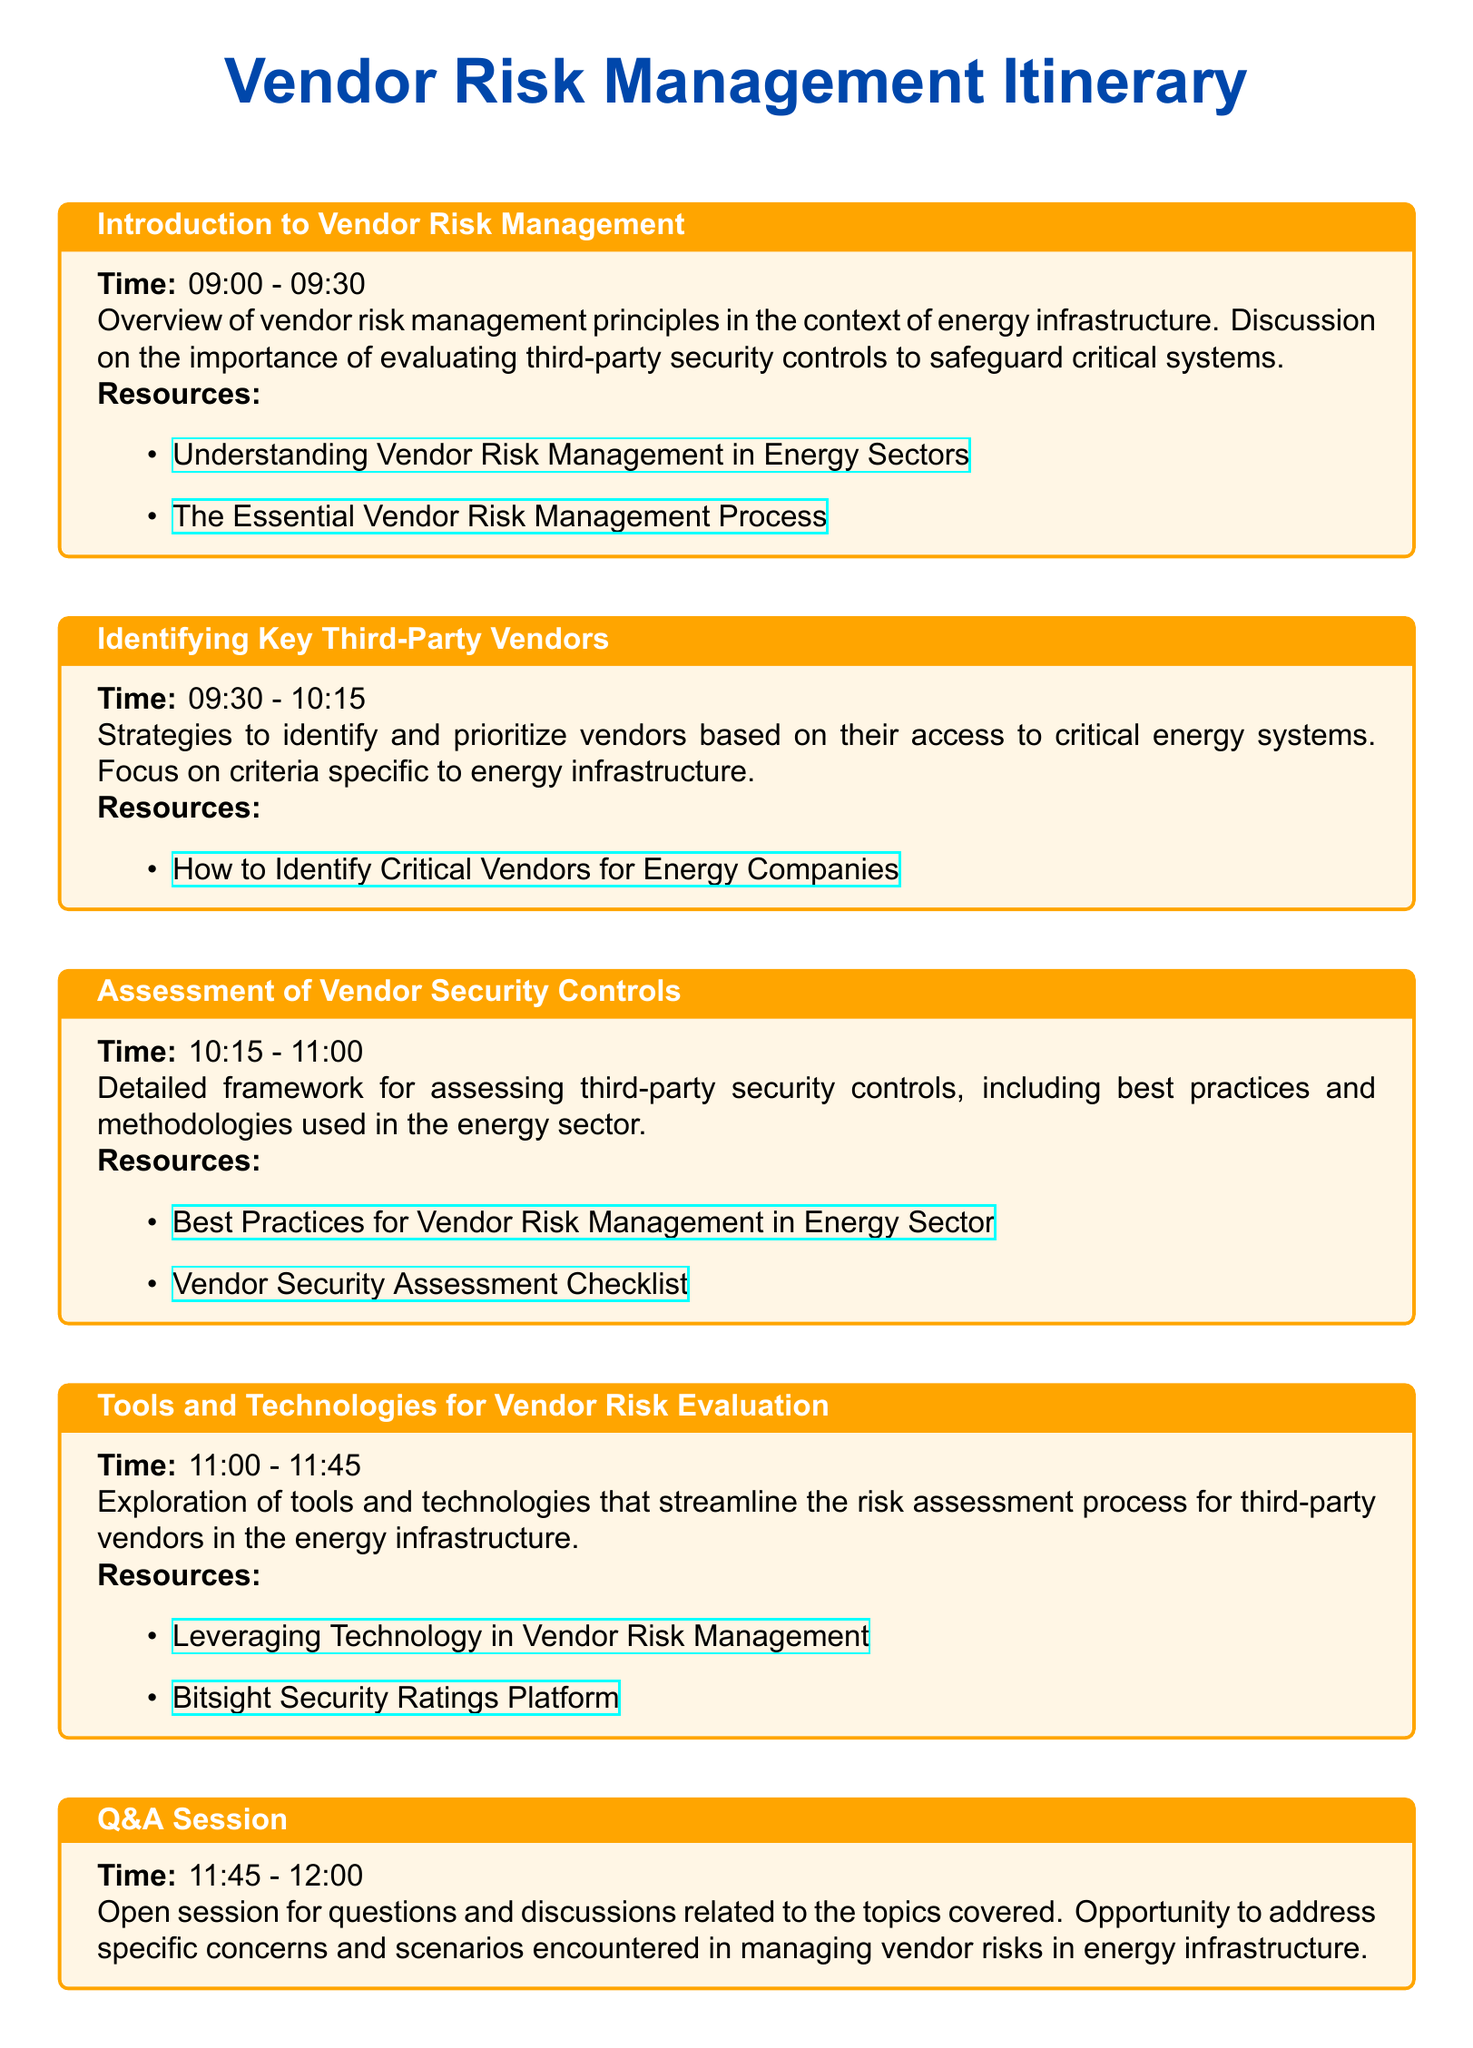What time does the Q&A session start? The Q&A session starts at 11:45 as listed in the itinerary.
Answer: 11:45 What is one of the resources for identifying key third-party vendors? The document lists a specific resource related to identifying critical vendors for energy companies.
Answer: How to Identify Critical Vendors for Energy Companies Which section covers the assessment of vendor security controls? The section titled "Assessment of Vendor Security Controls" specifically addresses the topic of assessing security controls.
Answer: Assessment of Vendor Security Controls What is the duration of the Introduction to Vendor Risk Management session? The duration is specified as 30 minutes in the itinerary for the introduction session.
Answer: 30 minutes What time is the session on tools and technologies for vendor risk evaluation? The session on tools and technologies takes place from 11:00 to 11:45.
Answer: 11:00 - 11:45 What is a key focus during the "Identifying Key Third-Party Vendors" session? The focus is on strategies to identify and prioritize vendors in the context of energy infrastructure.
Answer: Prioritize vendors What is the color scheme used for the section titles? The section titles use the color that is defined as "cybersecblue" in the document.
Answer: Cybersecblue What type of session follows the tools and technologies discussion? The session following is an open Q&A session for questions and discussions.
Answer: Q&A session 